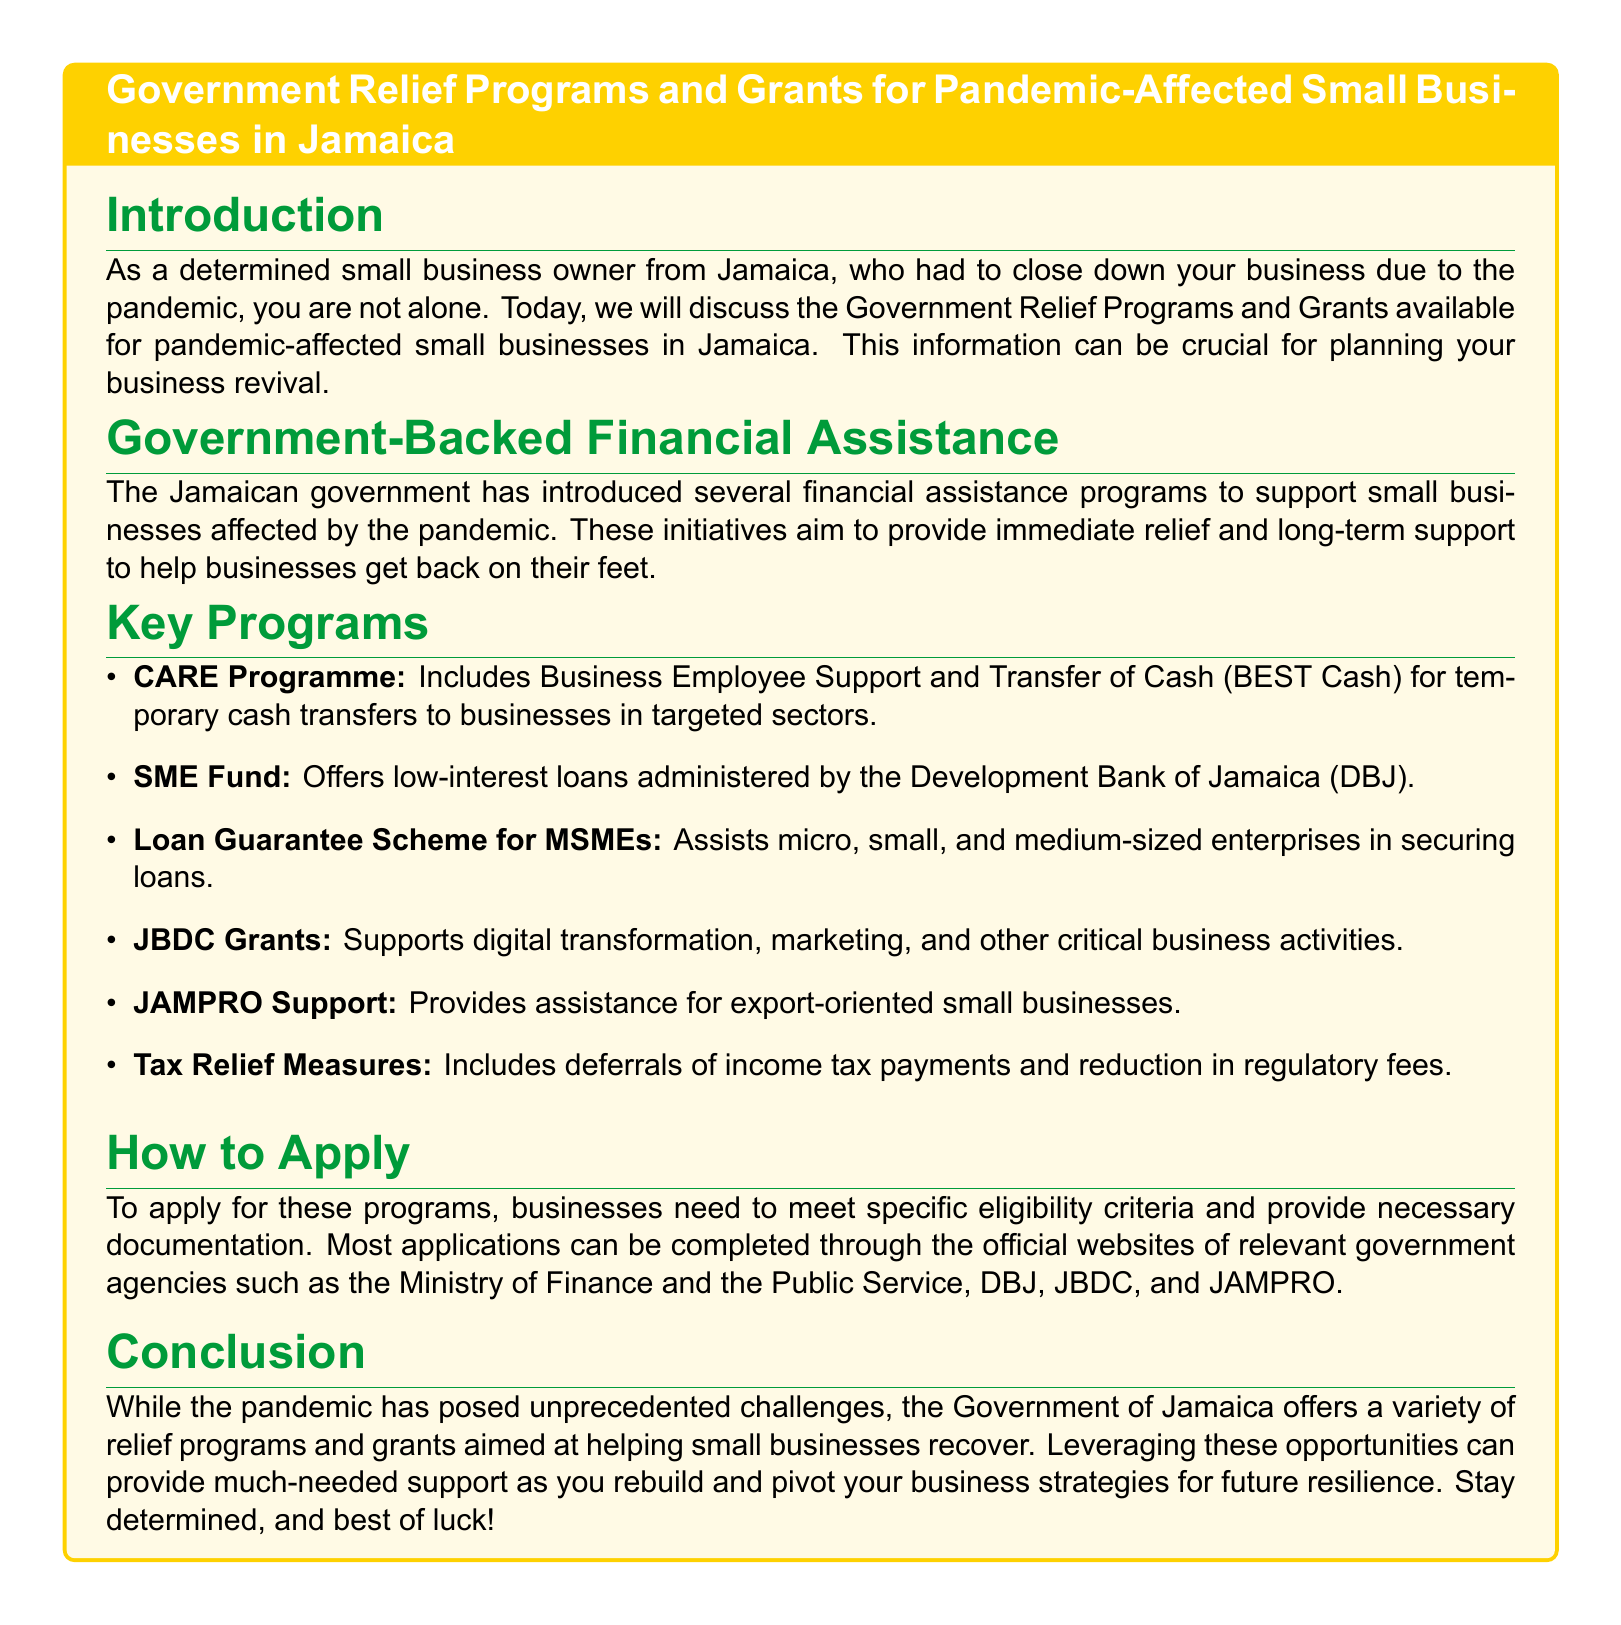What is the name of the program that includes Business Employee Support? The program that includes Business Employee Support is the CARE Programme.
Answer: CARE Programme What type of loans does the SME Fund offer? The SME Fund offers low-interest loans.
Answer: low-interest loans Which organization administers the SME Fund? The SME Fund is administered by the Development Bank of Jamaica (DBJ).
Answer: Development Bank of Jamaica (DBJ) What assistance does the Loan Guarantee Scheme provide? The Loan Guarantee Scheme assists enterprises in securing loans.
Answer: securing loans What type of support do JBDC Grants provide? JBDC Grants support digital transformation, marketing, and other critical business activities.
Answer: digital transformation, marketing, and other critical business activities Which government entity publishes the application details for the programs? Applications can be completed through official websites of relevant government agencies.
Answer: relevant government agencies What are the Tax Relief Measures aimed at? The Tax Relief Measures include deferrals of income tax payments and reduction in regulatory fees.
Answer: deferrals of income tax payments and reduction in regulatory fees What is the primary audience addressed in the introduction? The primary audience addressed is small business owners affected by the pandemic.
Answer: small business owners What is the overall theme of the document? The overall theme is about Government Relief Programs and Grants for small businesses affected by the pandemic.
Answer: Government Relief Programs and Grants for small businesses affected by the pandemic 